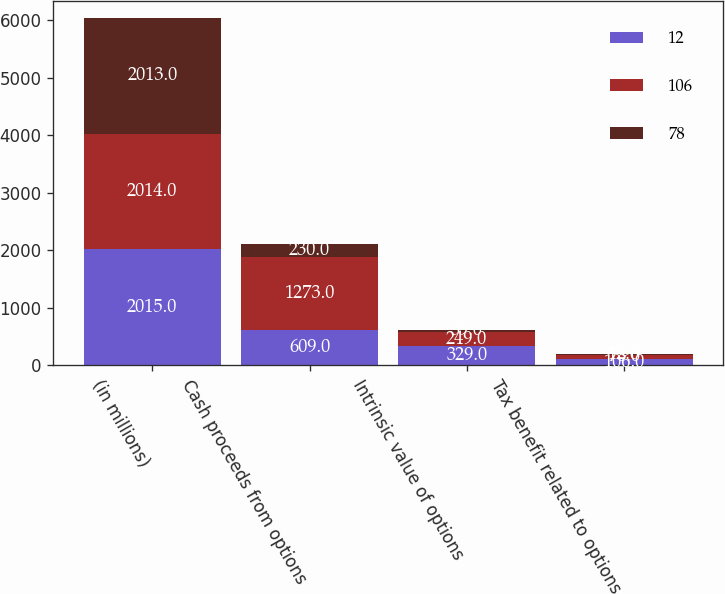Convert chart. <chart><loc_0><loc_0><loc_500><loc_500><stacked_bar_chart><ecel><fcel>(in millions)<fcel>Cash proceeds from options<fcel>Intrinsic value of options<fcel>Tax benefit related to options<nl><fcel>12<fcel>2015<fcel>609<fcel>329<fcel>106<nl><fcel>106<fcel>2014<fcel>1273<fcel>249<fcel>78<nl><fcel>78<fcel>2013<fcel>230<fcel>39<fcel>12<nl></chart> 